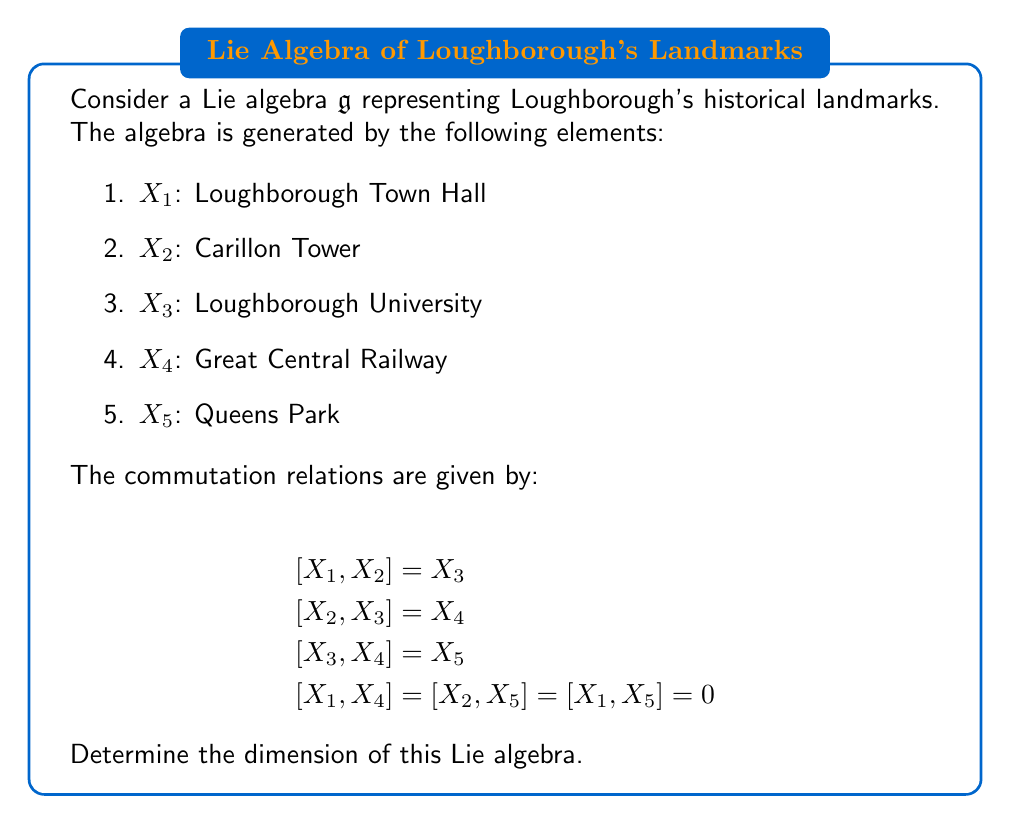Give your solution to this math problem. To determine the dimension of the Lie algebra $\mathfrak{g}$, we need to find the number of linearly independent generators. Let's approach this step-by-step:

1) First, we have 5 given generators: $X_1, X_2, X_3, X_4, X_5$.

2) We need to check if any of these can be expressed as linear combinations of others through the given commutation relations.

3) From the given relations:
   - $X_3 = [X_1, X_2]$
   - $X_4 = [X_2, X_3] = [X_2, [X_1, X_2]]$
   - $X_5 = [X_3, X_4] = [[X_1, X_2], [X_2, [X_1, X_2]]]$

4) We can see that $X_3, X_4,$ and $X_5$ can be expressed in terms of $X_1$ and $X_2$.

5) There are no relations that allow us to express $X_1$ or $X_2$ in terms of each other.

6) Therefore, $X_1$ and $X_2$ form a basis for this Lie algebra.

7) The dimension of a Lie algebra is equal to the number of elements in its basis.

Thus, the Lie algebra $\mathfrak{g}$ has a dimension of 2.
Answer: 2 